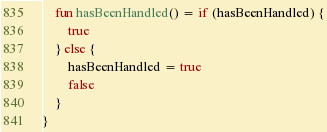Convert code to text. <code><loc_0><loc_0><loc_500><loc_500><_Kotlin_>
    fun hasBeenHandled() = if (hasBeenHandled) {
        true
    } else {
        hasBeenHandled = true
        false
    }
}
</code> 